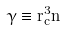Convert formula to latex. <formula><loc_0><loc_0><loc_500><loc_500>\gamma \equiv r _ { c } ^ { 3 } n</formula> 